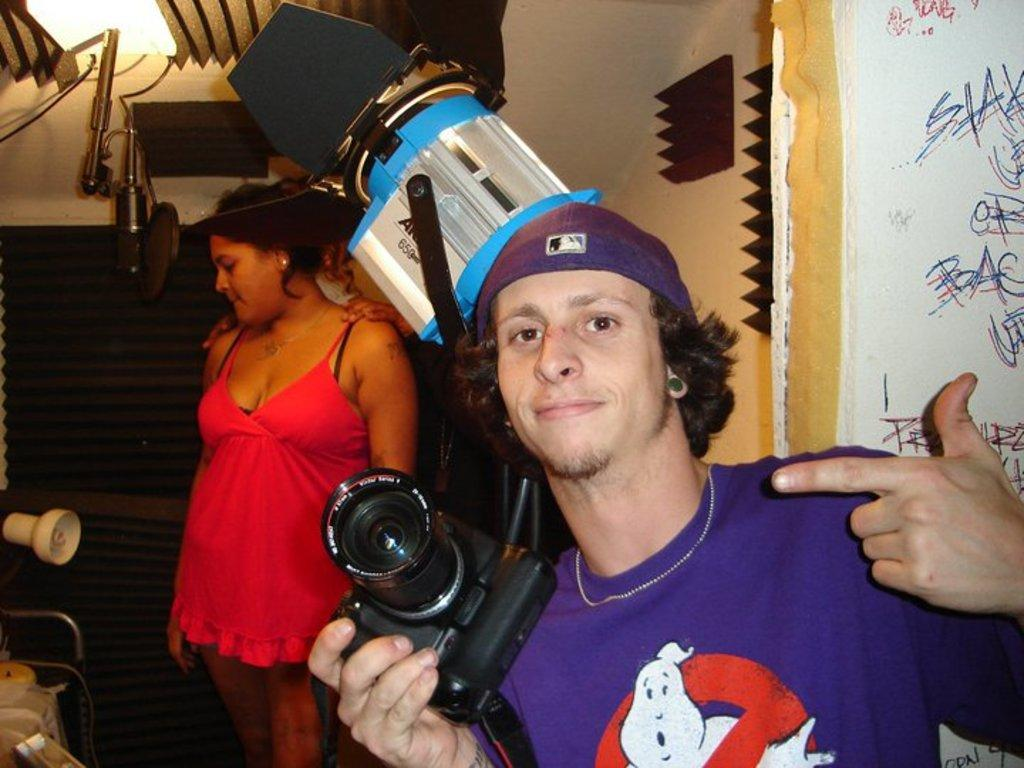What is the man in the image doing? The man is smiling and holding a camera in the image. Can you describe the woman in the background of the image? The woman is standing in the background of the image. What objects can be seen in the image besides the man and woman? There are equipment and a light visible in the image. What type of structure is present in the image? There is a wall in the image. What type of boundary is visible in the image? There is no boundary present in the image. Can you tell me how many army personnel are visible in the image? There are no army personnel present in the image. 